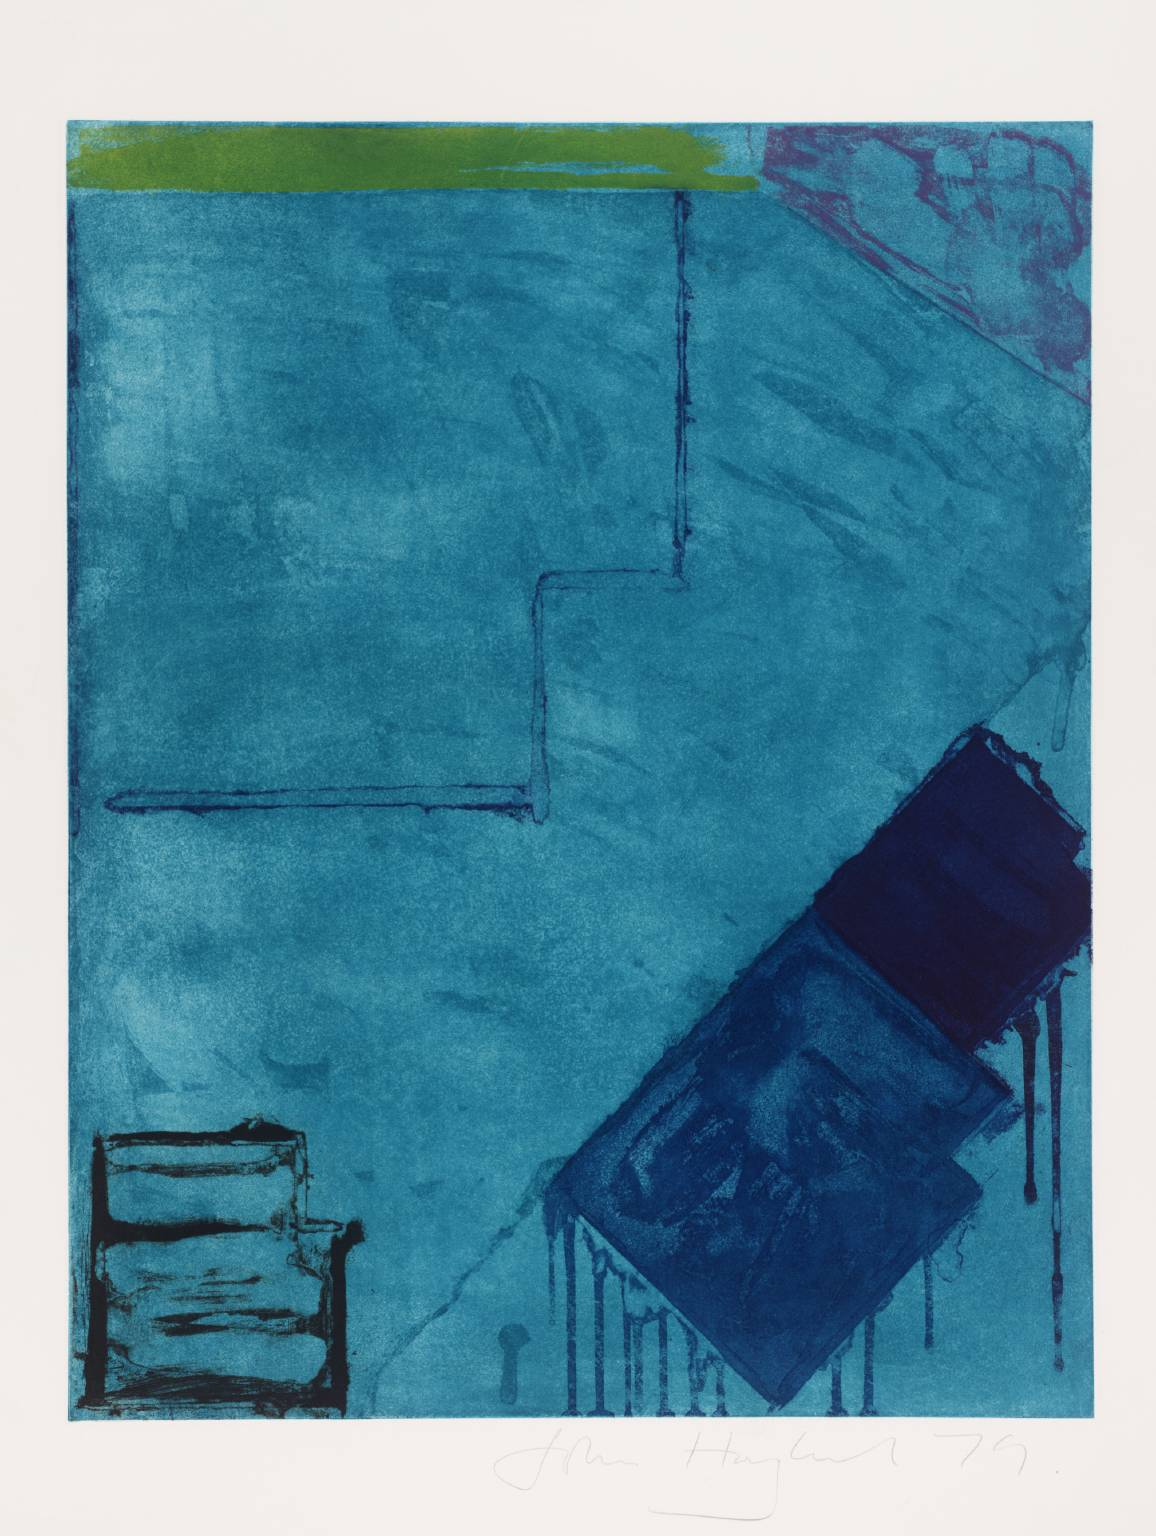How does the color scheme contribute to the mood of the piece? The cool dominance of blue hues intertwined with occasional bursts of green and pinkish-red evokes a sense of calm with underlying layers of complexity and contrast. The choice of colors can suggest depth and introspection, while the unexpected stripes of color add energy and a hint of surprise, disrupting the tranquility of the blue and inviting contemplation on the nature of the artwork. 